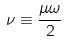Convert formula to latex. <formula><loc_0><loc_0><loc_500><loc_500>\nu \equiv \frac { \mu \omega } { 2 }</formula> 